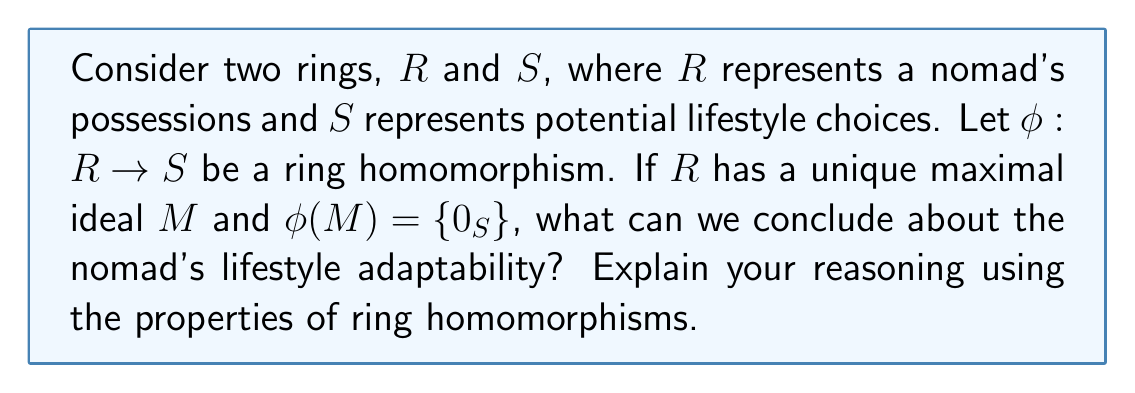Give your solution to this math problem. To answer this question, let's break it down step-by-step:

1) First, recall the definition of a ring homomorphism. A function $\phi: R \rightarrow S$ is a ring homomorphism if for all $a, b \in R$:
   
   a) $\phi(a + b) = \phi(a) + \phi(b)$
   b) $\phi(ab) = \phi(a)\phi(b)$
   c) $\phi(1_R) = 1_S$

2) Now, let's consider the given information:
   - $R$ has a unique maximal ideal $M$
   - $\phi(M) = \{0_S\}$

3) In ring theory, the kernel of a homomorphism $\phi$ is defined as:
   
   $\ker(\phi) = \{r \in R : \phi(r) = 0_S\}$

4) From the given information, we can conclude that $M \subseteq \ker(\phi)$

5) A fundamental theorem in ring theory states that for any ring homomorphism $\phi: R \rightarrow S$, the quotient ring $R/\ker(\phi)$ is isomorphic to the image of $\phi$ in $S$.

6) Since $M$ is the unique maximal ideal of $R$, and $M \subseteq \ker(\phi)$, we can conclude that $\ker(\phi) = M$

7) Therefore, $R/M \cong \text{Im}(\phi)$

8) In ring theory, when $R$ has a unique maximal ideal $M$, $R/M$ is a field.

9) This implies that $\text{Im}(\phi)$ is also a field.

In the context of our nomadic lifestyle analogy:
- $R$ representing possessions implies that the nomad has streamlined their belongings to the essential (represented by the field structure).
- The homomorphism $\phi$ mapping to $S$ (potential lifestyle choices) results in a field structure, implying that the nomad's choices are also streamlined and essential.

This suggests high adaptability, as the nomad's possessions and lifestyle choices are reduced to the most fundamental and versatile elements, allowing for easy transitions between different environments or situations.
Answer: The nomad's lifestyle is highly adaptable. The ring homomorphism $\phi: R \rightarrow S$ with $\ker(\phi) = M$ results in $\text{Im}(\phi)$ being a field, indicating that both the nomad's possessions and lifestyle choices are reduced to essential, versatile elements, facilitating easy adaptation to various environments. 